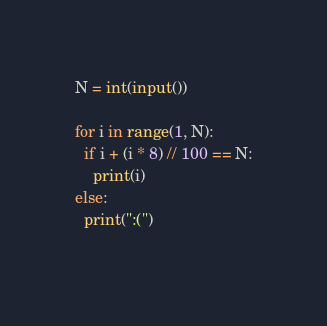<code> <loc_0><loc_0><loc_500><loc_500><_Python_>N = int(input())

for i in range(1, N):
  if i + (i * 8) // 100 == N:
    print(i)
else:
  print(":(")
    </code> 